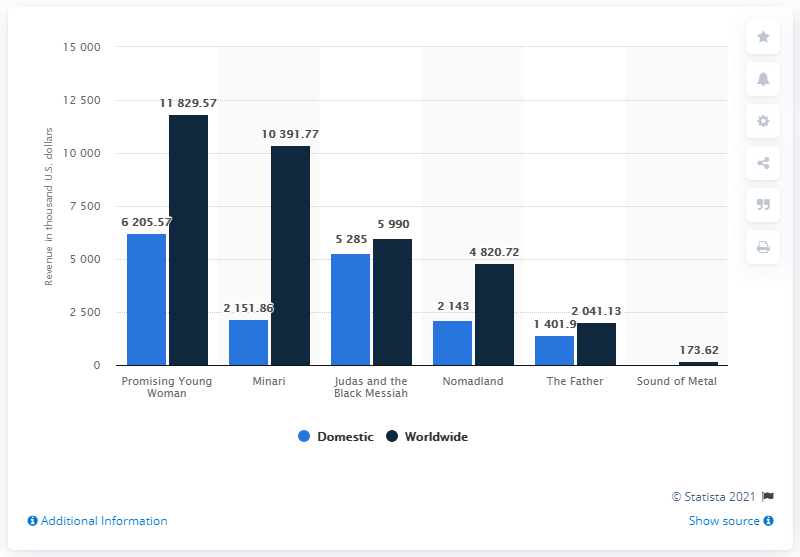Draw attention to some important aspects in this diagram. The 2021 Academy Awards nominated a film titled "Promising Young Woman" for the category of "Best Picture. 